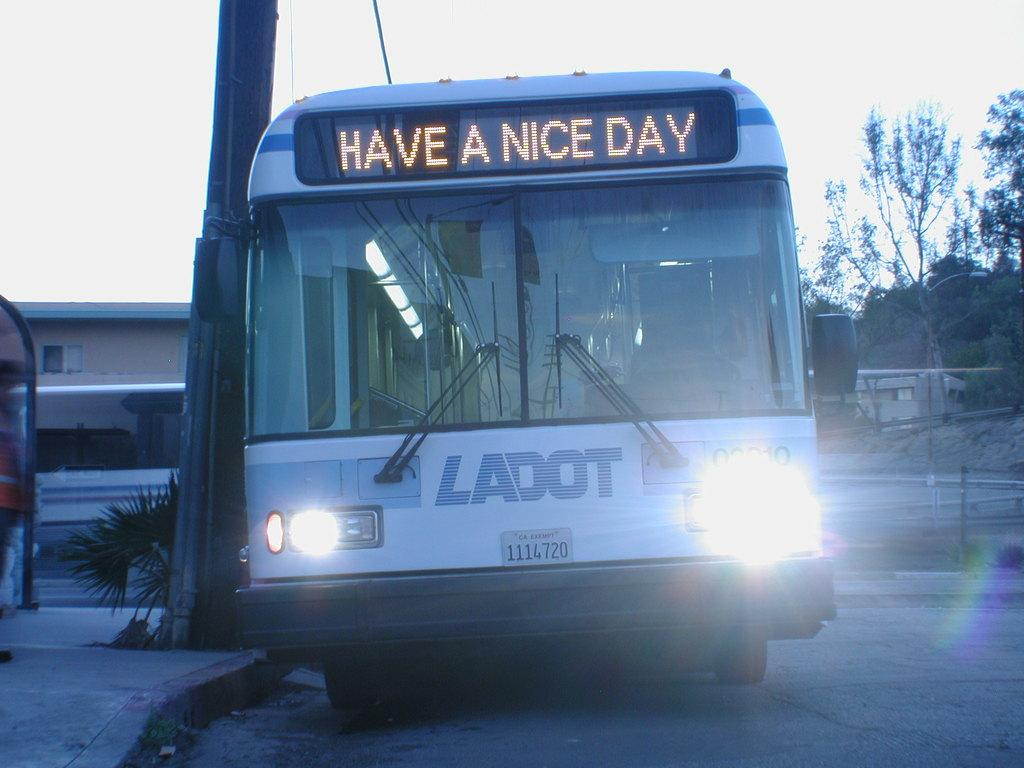<image>
Render a clear and concise summary of the photo. A bus that says "have a nice day" at the front. 